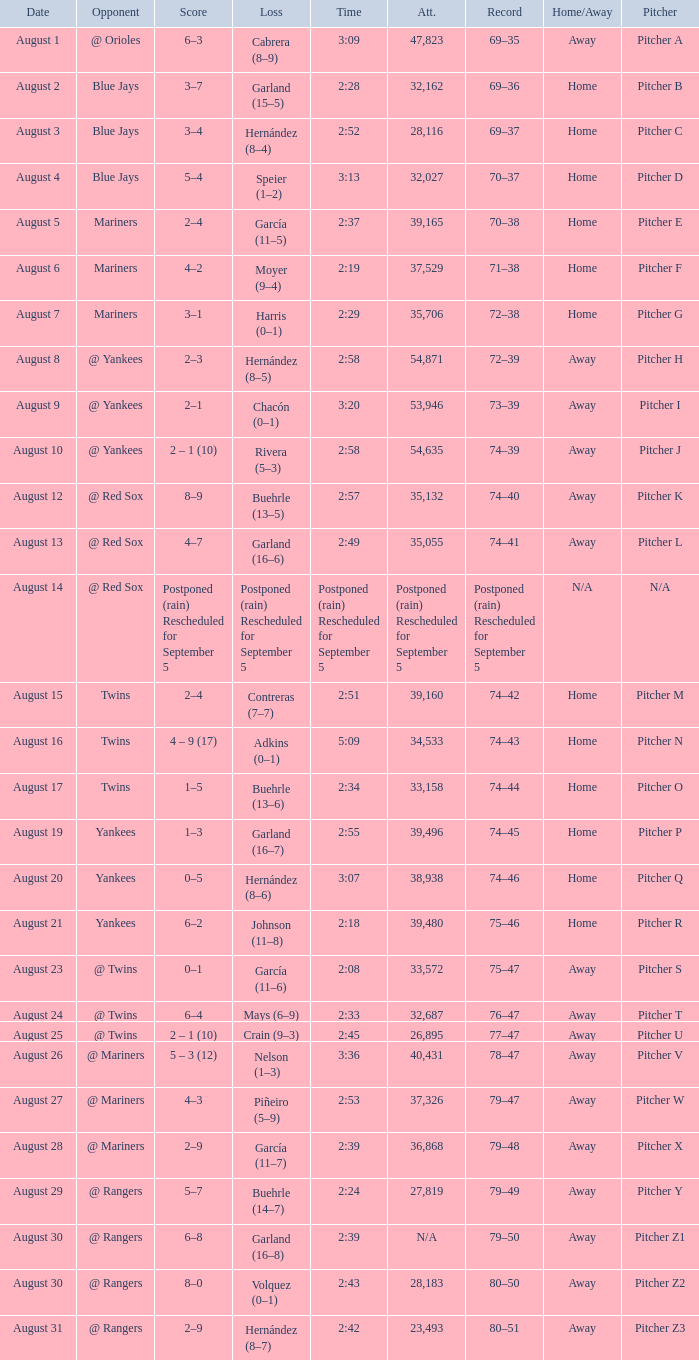Who lost on August 27? Piñeiro (5–9). 